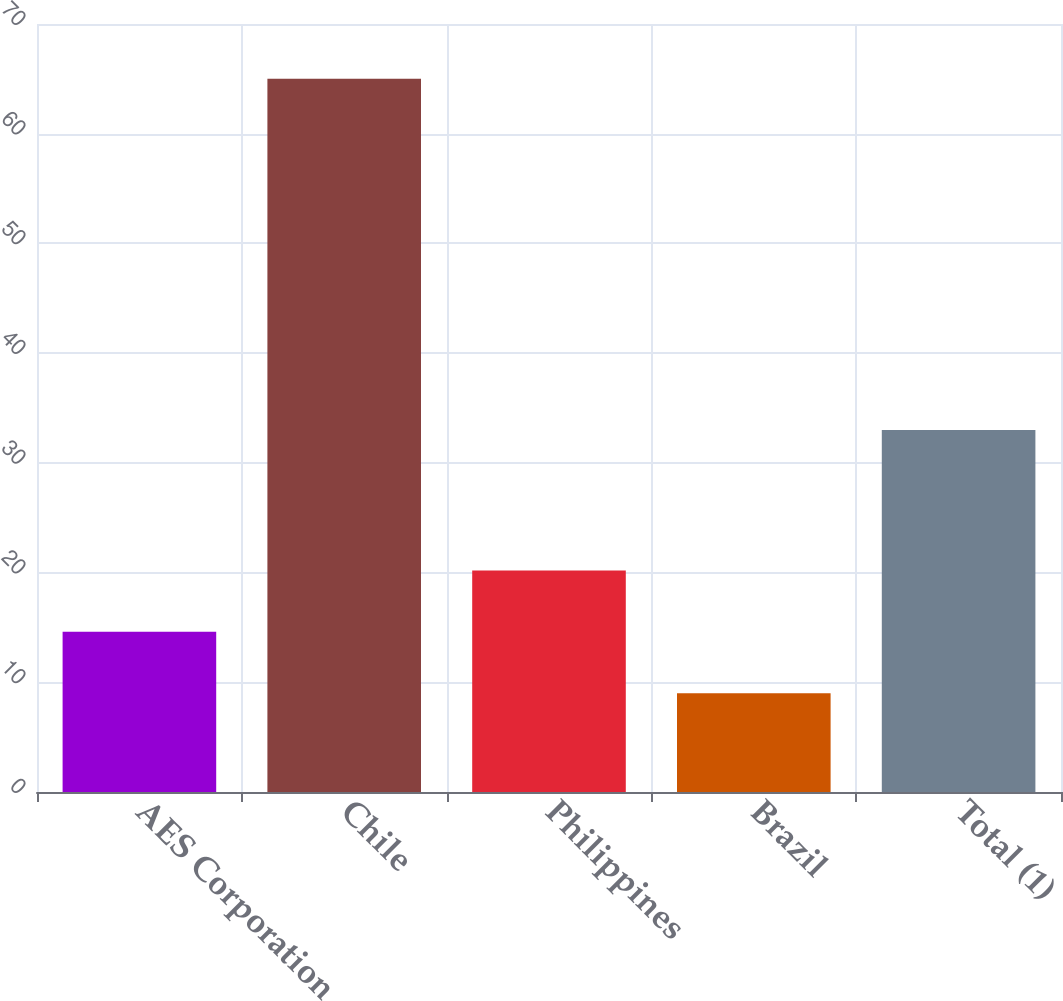Convert chart. <chart><loc_0><loc_0><loc_500><loc_500><bar_chart><fcel>AES Corporation<fcel>Chile<fcel>Philippines<fcel>Brazil<fcel>Total (1)<nl><fcel>14.6<fcel>65<fcel>20.2<fcel>9<fcel>33<nl></chart> 